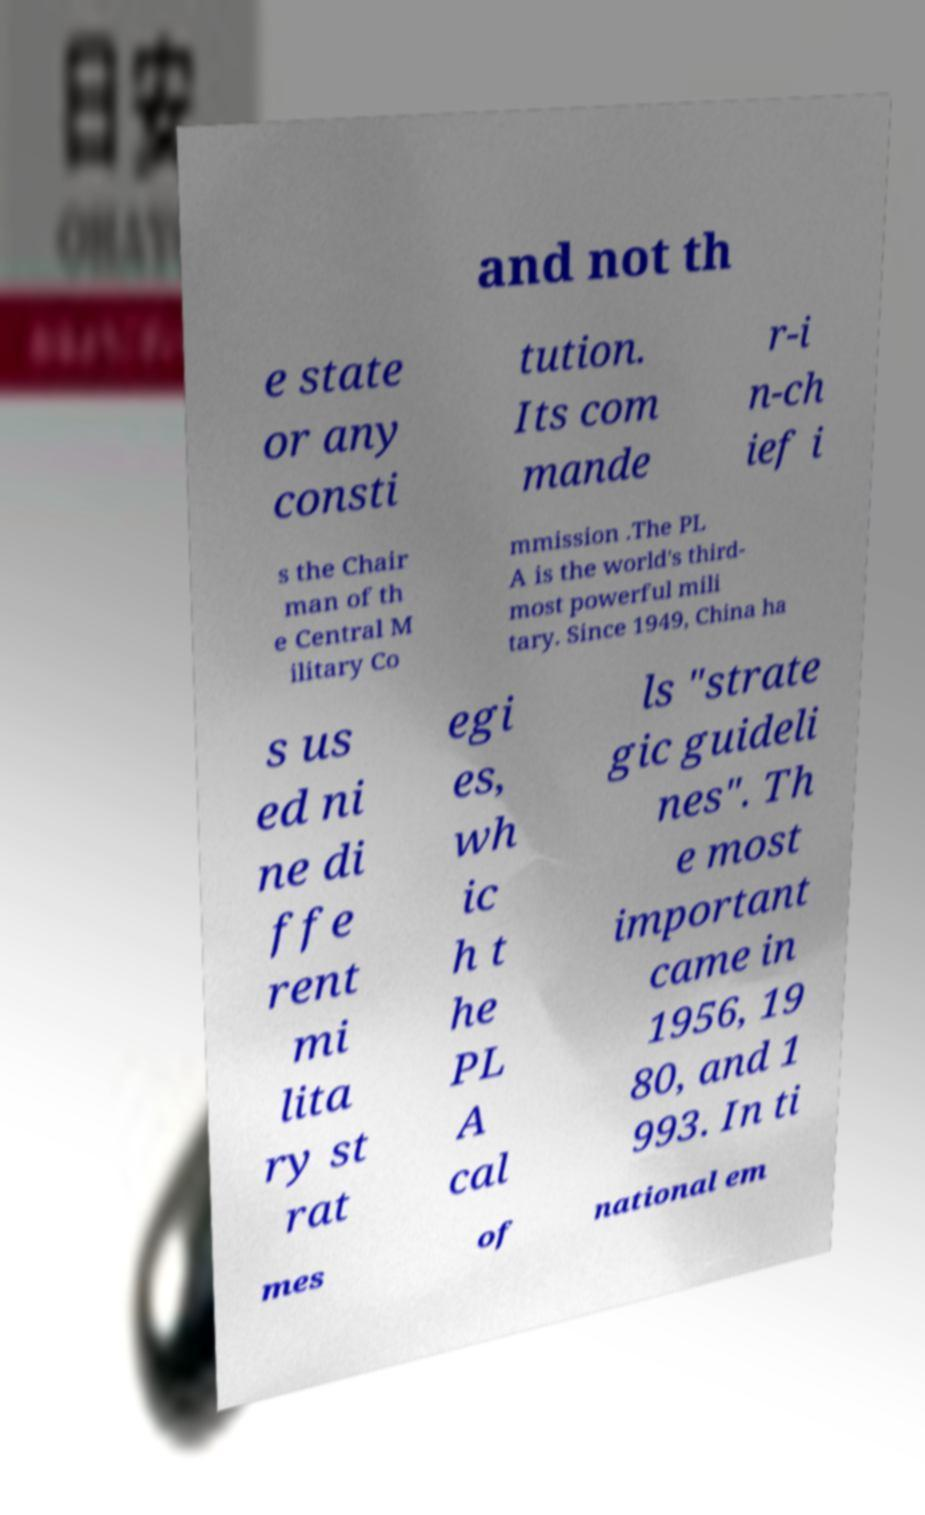Please read and relay the text visible in this image. What does it say? and not th e state or any consti tution. Its com mande r-i n-ch ief i s the Chair man of th e Central M ilitary Co mmission .The PL A is the world's third- most powerful mili tary. Since 1949, China ha s us ed ni ne di ffe rent mi lita ry st rat egi es, wh ic h t he PL A cal ls "strate gic guideli nes". Th e most important came in 1956, 19 80, and 1 993. In ti mes of national em 